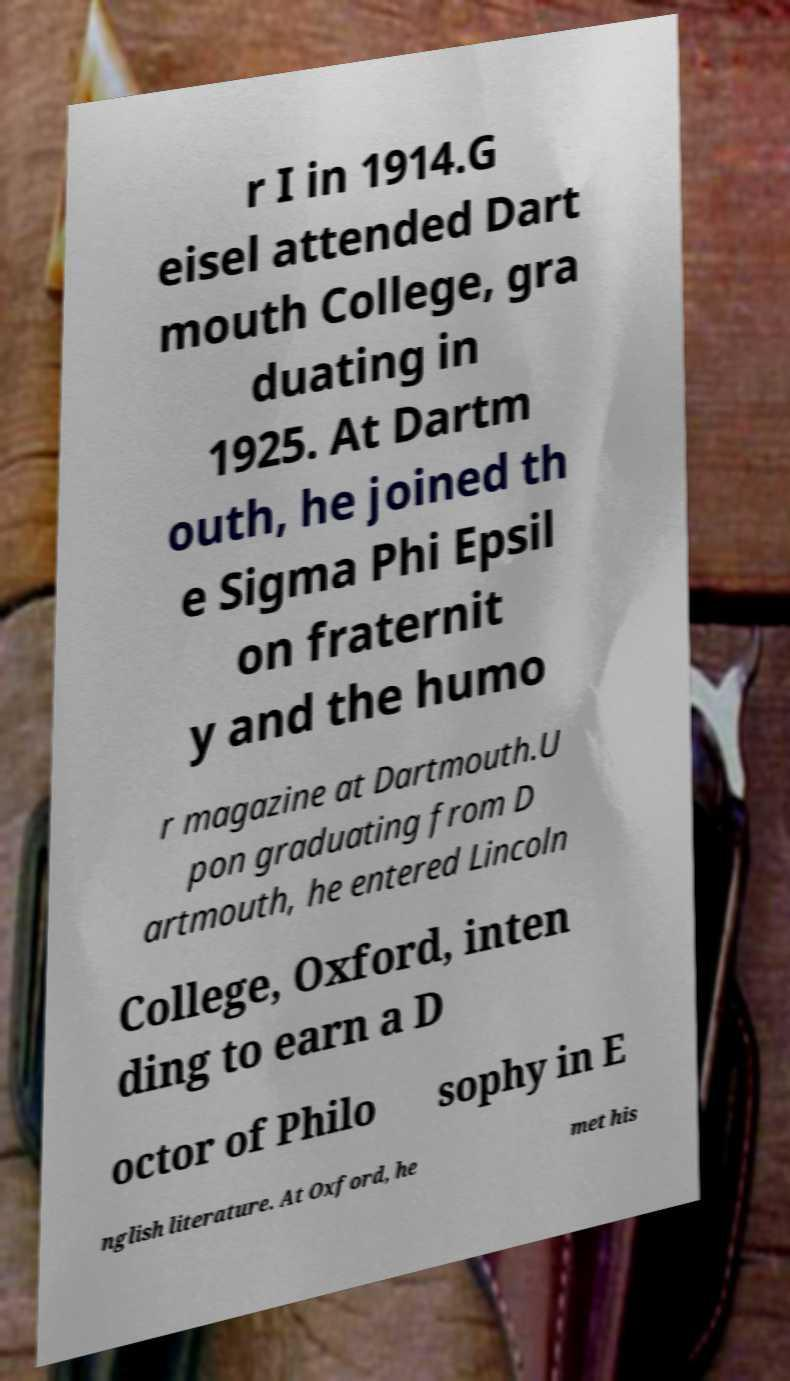For documentation purposes, I need the text within this image transcribed. Could you provide that? r I in 1914.G eisel attended Dart mouth College, gra duating in 1925. At Dartm outh, he joined th e Sigma Phi Epsil on fraternit y and the humo r magazine at Dartmouth.U pon graduating from D artmouth, he entered Lincoln College, Oxford, inten ding to earn a D octor of Philo sophy in E nglish literature. At Oxford, he met his 